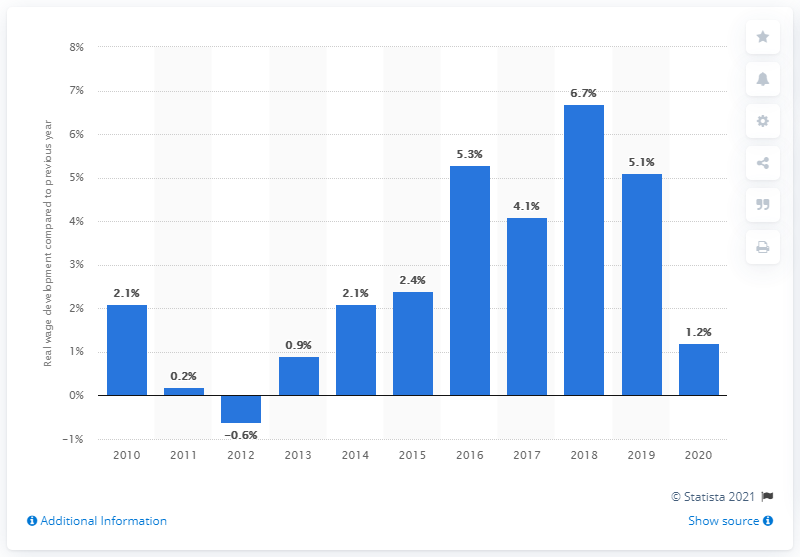Mention a couple of crucial points in this snapshot. According to statistics, the growth rate of Poland's real wages in 2019 was 5.1%. 